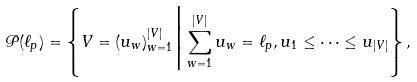Convert formula to latex. <formula><loc_0><loc_0><loc_500><loc_500>\mathcal { P } ( \ell _ { p } ) = \left \{ V = ( u _ { w } ) _ { w = 1 } ^ { | V | } \Big | \sum _ { w = 1 } ^ { | V | } u _ { w } = \ell _ { p } , u _ { 1 } \leq \dots \leq u _ { | V | } \right \} ,</formula> 